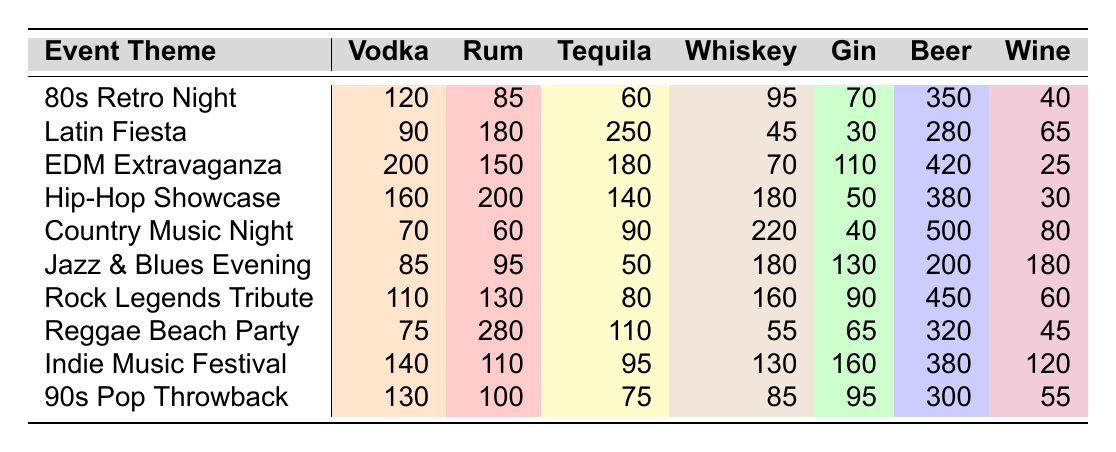What is the total amount of Beer sold on Hip-Hop Showcase night? From the table, the Beer sales on Hip-Hop Showcase night is directly listed as 380.
Answer: 380 Which themed night sold the highest amount of Rum? The maximum value in the Rum column is 280, found in the Reggae Beach Party row.
Answer: Reggae Beach Party What is the average number of Tequila sold across all events? To find the average of Tequila sold, sum all Tequila values (60 + 250 + 180 + 140 + 90 + 50 + 80 + 110 + 95 + 75 = 1030) and divide by the number of events (10), yielding an average of 1030/10 = 103.
Answer: 103 Was more Gin sold on Country Music Night than on Latin Fiesta? Country Music Night has 40 Gin sales, while Latin Fiesta has 30. Since 40 > 30, the statement is true.
Answer: Yes What is the difference in Vodka sales between EDM Extravaganza and Indie Music Festival? The Vodka sales for EDM Extravaganza is 200 and for Indie Music Festival is 140. The difference is 200 - 140 = 60.
Answer: 60 Which event had the lowest total drink sales? By summing each row (i.e., total sales) and comparing them: 80s Retro Night = 120 + 85 + 60 + 95 + 70 + 350 + 40 = 820; follow this process for each event. The minimum total is found with Jazz & Blues Evening = 1050.
Answer: 80s Retro Night How many total drinks were sold across all events? To calculate the total drinks sold, add all individual drink sales across all events, yielding a total of 80s Retro Night (820) + Latin Fiesta (1,060) + EDM Extravaganza (1,170) + Hip-Hop Showcase (1,250) + Country Music Night (1,150) + Jazz & Blues Evening (1,050) + Rock Legends Tribute (1,130) + Reggae Beach Party (1,030) + Indie Music Festival (1,210) + 90s Pop Throwback (1,095) = 11,115.
Answer: 11,115 Which event was the most successful in Whiskey sales? The max Whiskey sales were 220, identified in the Country Music Night row.
Answer: Country Music Night Is it true that more Wine was sold on Jazz & Blues Evening than on Hip-Hop Showcase? Jazz & Blues Evening shows 180 Wine sales while Hip-Hop Showcase shows 30. Since 180 > 30, the statement holds true.
Answer: Yes 